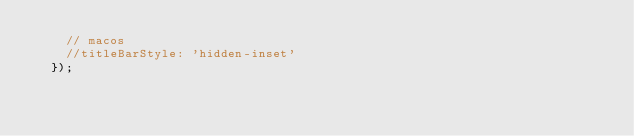<code> <loc_0><loc_0><loc_500><loc_500><_JavaScript_>		// macos
		//titleBarStyle: 'hidden-inset'
	});
</code> 